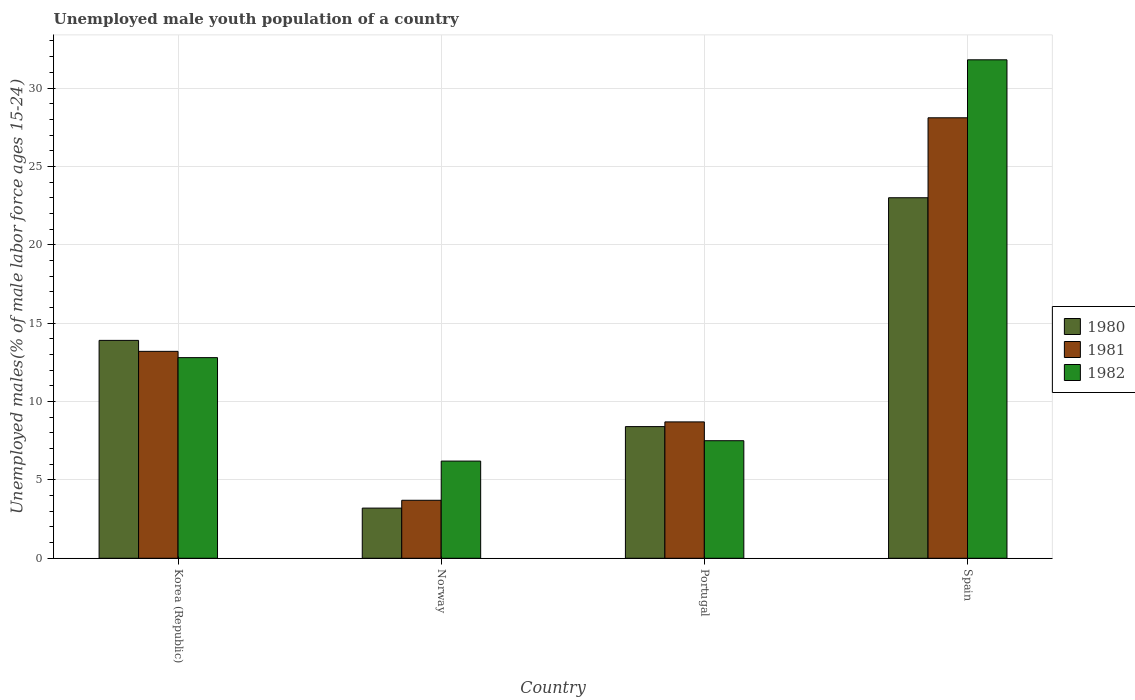How many different coloured bars are there?
Provide a succinct answer. 3. How many groups of bars are there?
Keep it short and to the point. 4. Are the number of bars on each tick of the X-axis equal?
Keep it short and to the point. Yes. What is the label of the 3rd group of bars from the left?
Your response must be concise. Portugal. What is the percentage of unemployed male youth population in 1980 in Portugal?
Make the answer very short. 8.4. Across all countries, what is the maximum percentage of unemployed male youth population in 1982?
Provide a short and direct response. 31.8. Across all countries, what is the minimum percentage of unemployed male youth population in 1981?
Provide a short and direct response. 3.7. In which country was the percentage of unemployed male youth population in 1981 maximum?
Your answer should be compact. Spain. In which country was the percentage of unemployed male youth population in 1980 minimum?
Provide a succinct answer. Norway. What is the total percentage of unemployed male youth population in 1982 in the graph?
Ensure brevity in your answer.  58.3. What is the difference between the percentage of unemployed male youth population in 1982 in Portugal and that in Spain?
Make the answer very short. -24.3. What is the difference between the percentage of unemployed male youth population in 1980 in Portugal and the percentage of unemployed male youth population in 1981 in Norway?
Your answer should be very brief. 4.7. What is the average percentage of unemployed male youth population in 1981 per country?
Offer a very short reply. 13.43. What is the difference between the percentage of unemployed male youth population of/in 1982 and percentage of unemployed male youth population of/in 1980 in Korea (Republic)?
Your response must be concise. -1.1. What is the ratio of the percentage of unemployed male youth population in 1980 in Korea (Republic) to that in Spain?
Provide a succinct answer. 0.6. Is the percentage of unemployed male youth population in 1980 in Korea (Republic) less than that in Portugal?
Offer a terse response. No. Is the difference between the percentage of unemployed male youth population in 1982 in Korea (Republic) and Spain greater than the difference between the percentage of unemployed male youth population in 1980 in Korea (Republic) and Spain?
Make the answer very short. No. What is the difference between the highest and the second highest percentage of unemployed male youth population in 1980?
Give a very brief answer. -5.5. What is the difference between the highest and the lowest percentage of unemployed male youth population in 1982?
Your response must be concise. 25.6. What does the 2nd bar from the right in Korea (Republic) represents?
Provide a succinct answer. 1981. Is it the case that in every country, the sum of the percentage of unemployed male youth population in 1981 and percentage of unemployed male youth population in 1980 is greater than the percentage of unemployed male youth population in 1982?
Give a very brief answer. Yes. How many countries are there in the graph?
Make the answer very short. 4. Are the values on the major ticks of Y-axis written in scientific E-notation?
Ensure brevity in your answer.  No. Does the graph contain any zero values?
Provide a succinct answer. No. Does the graph contain grids?
Provide a succinct answer. Yes. How many legend labels are there?
Your answer should be very brief. 3. What is the title of the graph?
Your answer should be compact. Unemployed male youth population of a country. Does "2011" appear as one of the legend labels in the graph?
Provide a succinct answer. No. What is the label or title of the Y-axis?
Your answer should be very brief. Unemployed males(% of male labor force ages 15-24). What is the Unemployed males(% of male labor force ages 15-24) in 1980 in Korea (Republic)?
Your answer should be compact. 13.9. What is the Unemployed males(% of male labor force ages 15-24) of 1981 in Korea (Republic)?
Make the answer very short. 13.2. What is the Unemployed males(% of male labor force ages 15-24) of 1982 in Korea (Republic)?
Keep it short and to the point. 12.8. What is the Unemployed males(% of male labor force ages 15-24) of 1980 in Norway?
Your answer should be very brief. 3.2. What is the Unemployed males(% of male labor force ages 15-24) of 1981 in Norway?
Offer a terse response. 3.7. What is the Unemployed males(% of male labor force ages 15-24) of 1982 in Norway?
Provide a succinct answer. 6.2. What is the Unemployed males(% of male labor force ages 15-24) of 1980 in Portugal?
Your answer should be very brief. 8.4. What is the Unemployed males(% of male labor force ages 15-24) of 1981 in Portugal?
Your answer should be very brief. 8.7. What is the Unemployed males(% of male labor force ages 15-24) in 1980 in Spain?
Provide a succinct answer. 23. What is the Unemployed males(% of male labor force ages 15-24) of 1981 in Spain?
Your response must be concise. 28.1. What is the Unemployed males(% of male labor force ages 15-24) in 1982 in Spain?
Ensure brevity in your answer.  31.8. Across all countries, what is the maximum Unemployed males(% of male labor force ages 15-24) in 1980?
Ensure brevity in your answer.  23. Across all countries, what is the maximum Unemployed males(% of male labor force ages 15-24) in 1981?
Provide a short and direct response. 28.1. Across all countries, what is the maximum Unemployed males(% of male labor force ages 15-24) of 1982?
Keep it short and to the point. 31.8. Across all countries, what is the minimum Unemployed males(% of male labor force ages 15-24) in 1980?
Keep it short and to the point. 3.2. Across all countries, what is the minimum Unemployed males(% of male labor force ages 15-24) in 1981?
Make the answer very short. 3.7. Across all countries, what is the minimum Unemployed males(% of male labor force ages 15-24) in 1982?
Keep it short and to the point. 6.2. What is the total Unemployed males(% of male labor force ages 15-24) of 1980 in the graph?
Your response must be concise. 48.5. What is the total Unemployed males(% of male labor force ages 15-24) of 1981 in the graph?
Your answer should be compact. 53.7. What is the total Unemployed males(% of male labor force ages 15-24) in 1982 in the graph?
Provide a succinct answer. 58.3. What is the difference between the Unemployed males(% of male labor force ages 15-24) in 1980 in Korea (Republic) and that in Norway?
Offer a terse response. 10.7. What is the difference between the Unemployed males(% of male labor force ages 15-24) of 1982 in Korea (Republic) and that in Portugal?
Ensure brevity in your answer.  5.3. What is the difference between the Unemployed males(% of male labor force ages 15-24) in 1981 in Korea (Republic) and that in Spain?
Your answer should be very brief. -14.9. What is the difference between the Unemployed males(% of male labor force ages 15-24) in 1980 in Norway and that in Spain?
Provide a succinct answer. -19.8. What is the difference between the Unemployed males(% of male labor force ages 15-24) in 1981 in Norway and that in Spain?
Make the answer very short. -24.4. What is the difference between the Unemployed males(% of male labor force ages 15-24) of 1982 in Norway and that in Spain?
Offer a very short reply. -25.6. What is the difference between the Unemployed males(% of male labor force ages 15-24) of 1980 in Portugal and that in Spain?
Keep it short and to the point. -14.6. What is the difference between the Unemployed males(% of male labor force ages 15-24) in 1981 in Portugal and that in Spain?
Your response must be concise. -19.4. What is the difference between the Unemployed males(% of male labor force ages 15-24) of 1982 in Portugal and that in Spain?
Your response must be concise. -24.3. What is the difference between the Unemployed males(% of male labor force ages 15-24) in 1980 in Korea (Republic) and the Unemployed males(% of male labor force ages 15-24) in 1981 in Norway?
Make the answer very short. 10.2. What is the difference between the Unemployed males(% of male labor force ages 15-24) in 1980 in Korea (Republic) and the Unemployed males(% of male labor force ages 15-24) in 1982 in Norway?
Your answer should be compact. 7.7. What is the difference between the Unemployed males(% of male labor force ages 15-24) in 1981 in Korea (Republic) and the Unemployed males(% of male labor force ages 15-24) in 1982 in Norway?
Your answer should be very brief. 7. What is the difference between the Unemployed males(% of male labor force ages 15-24) in 1980 in Korea (Republic) and the Unemployed males(% of male labor force ages 15-24) in 1981 in Portugal?
Your answer should be compact. 5.2. What is the difference between the Unemployed males(% of male labor force ages 15-24) in 1980 in Korea (Republic) and the Unemployed males(% of male labor force ages 15-24) in 1981 in Spain?
Give a very brief answer. -14.2. What is the difference between the Unemployed males(% of male labor force ages 15-24) of 1980 in Korea (Republic) and the Unemployed males(% of male labor force ages 15-24) of 1982 in Spain?
Provide a short and direct response. -17.9. What is the difference between the Unemployed males(% of male labor force ages 15-24) of 1981 in Korea (Republic) and the Unemployed males(% of male labor force ages 15-24) of 1982 in Spain?
Ensure brevity in your answer.  -18.6. What is the difference between the Unemployed males(% of male labor force ages 15-24) in 1980 in Norway and the Unemployed males(% of male labor force ages 15-24) in 1981 in Portugal?
Make the answer very short. -5.5. What is the difference between the Unemployed males(% of male labor force ages 15-24) of 1981 in Norway and the Unemployed males(% of male labor force ages 15-24) of 1982 in Portugal?
Provide a succinct answer. -3.8. What is the difference between the Unemployed males(% of male labor force ages 15-24) of 1980 in Norway and the Unemployed males(% of male labor force ages 15-24) of 1981 in Spain?
Make the answer very short. -24.9. What is the difference between the Unemployed males(% of male labor force ages 15-24) in 1980 in Norway and the Unemployed males(% of male labor force ages 15-24) in 1982 in Spain?
Your answer should be very brief. -28.6. What is the difference between the Unemployed males(% of male labor force ages 15-24) of 1981 in Norway and the Unemployed males(% of male labor force ages 15-24) of 1982 in Spain?
Give a very brief answer. -28.1. What is the difference between the Unemployed males(% of male labor force ages 15-24) of 1980 in Portugal and the Unemployed males(% of male labor force ages 15-24) of 1981 in Spain?
Offer a terse response. -19.7. What is the difference between the Unemployed males(% of male labor force ages 15-24) in 1980 in Portugal and the Unemployed males(% of male labor force ages 15-24) in 1982 in Spain?
Provide a succinct answer. -23.4. What is the difference between the Unemployed males(% of male labor force ages 15-24) in 1981 in Portugal and the Unemployed males(% of male labor force ages 15-24) in 1982 in Spain?
Your response must be concise. -23.1. What is the average Unemployed males(% of male labor force ages 15-24) of 1980 per country?
Give a very brief answer. 12.12. What is the average Unemployed males(% of male labor force ages 15-24) of 1981 per country?
Offer a very short reply. 13.43. What is the average Unemployed males(% of male labor force ages 15-24) of 1982 per country?
Offer a very short reply. 14.57. What is the difference between the Unemployed males(% of male labor force ages 15-24) of 1981 and Unemployed males(% of male labor force ages 15-24) of 1982 in Korea (Republic)?
Keep it short and to the point. 0.4. What is the difference between the Unemployed males(% of male labor force ages 15-24) of 1980 and Unemployed males(% of male labor force ages 15-24) of 1981 in Norway?
Provide a short and direct response. -0.5. What is the difference between the Unemployed males(% of male labor force ages 15-24) in 1980 and Unemployed males(% of male labor force ages 15-24) in 1982 in Norway?
Offer a terse response. -3. What is the difference between the Unemployed males(% of male labor force ages 15-24) in 1981 and Unemployed males(% of male labor force ages 15-24) in 1982 in Norway?
Keep it short and to the point. -2.5. What is the difference between the Unemployed males(% of male labor force ages 15-24) of 1980 and Unemployed males(% of male labor force ages 15-24) of 1982 in Portugal?
Offer a terse response. 0.9. What is the ratio of the Unemployed males(% of male labor force ages 15-24) of 1980 in Korea (Republic) to that in Norway?
Provide a succinct answer. 4.34. What is the ratio of the Unemployed males(% of male labor force ages 15-24) in 1981 in Korea (Republic) to that in Norway?
Your answer should be compact. 3.57. What is the ratio of the Unemployed males(% of male labor force ages 15-24) in 1982 in Korea (Republic) to that in Norway?
Provide a succinct answer. 2.06. What is the ratio of the Unemployed males(% of male labor force ages 15-24) of 1980 in Korea (Republic) to that in Portugal?
Your response must be concise. 1.65. What is the ratio of the Unemployed males(% of male labor force ages 15-24) of 1981 in Korea (Republic) to that in Portugal?
Offer a very short reply. 1.52. What is the ratio of the Unemployed males(% of male labor force ages 15-24) in 1982 in Korea (Republic) to that in Portugal?
Provide a succinct answer. 1.71. What is the ratio of the Unemployed males(% of male labor force ages 15-24) of 1980 in Korea (Republic) to that in Spain?
Provide a short and direct response. 0.6. What is the ratio of the Unemployed males(% of male labor force ages 15-24) in 1981 in Korea (Republic) to that in Spain?
Your answer should be compact. 0.47. What is the ratio of the Unemployed males(% of male labor force ages 15-24) in 1982 in Korea (Republic) to that in Spain?
Make the answer very short. 0.4. What is the ratio of the Unemployed males(% of male labor force ages 15-24) in 1980 in Norway to that in Portugal?
Give a very brief answer. 0.38. What is the ratio of the Unemployed males(% of male labor force ages 15-24) of 1981 in Norway to that in Portugal?
Your answer should be compact. 0.43. What is the ratio of the Unemployed males(% of male labor force ages 15-24) in 1982 in Norway to that in Portugal?
Keep it short and to the point. 0.83. What is the ratio of the Unemployed males(% of male labor force ages 15-24) of 1980 in Norway to that in Spain?
Your response must be concise. 0.14. What is the ratio of the Unemployed males(% of male labor force ages 15-24) of 1981 in Norway to that in Spain?
Ensure brevity in your answer.  0.13. What is the ratio of the Unemployed males(% of male labor force ages 15-24) in 1982 in Norway to that in Spain?
Provide a short and direct response. 0.2. What is the ratio of the Unemployed males(% of male labor force ages 15-24) in 1980 in Portugal to that in Spain?
Provide a short and direct response. 0.37. What is the ratio of the Unemployed males(% of male labor force ages 15-24) of 1981 in Portugal to that in Spain?
Offer a very short reply. 0.31. What is the ratio of the Unemployed males(% of male labor force ages 15-24) of 1982 in Portugal to that in Spain?
Your answer should be very brief. 0.24. What is the difference between the highest and the second highest Unemployed males(% of male labor force ages 15-24) of 1980?
Provide a short and direct response. 9.1. What is the difference between the highest and the second highest Unemployed males(% of male labor force ages 15-24) of 1981?
Offer a very short reply. 14.9. What is the difference between the highest and the lowest Unemployed males(% of male labor force ages 15-24) of 1980?
Your answer should be very brief. 19.8. What is the difference between the highest and the lowest Unemployed males(% of male labor force ages 15-24) in 1981?
Your answer should be compact. 24.4. What is the difference between the highest and the lowest Unemployed males(% of male labor force ages 15-24) of 1982?
Your answer should be very brief. 25.6. 